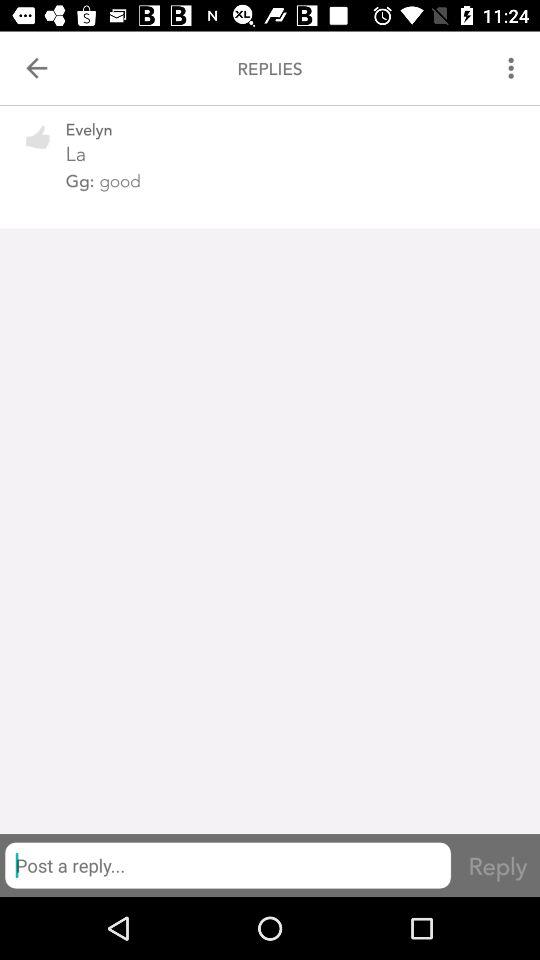What reply did "Gg" give? The reply of "Gg" was "good". 